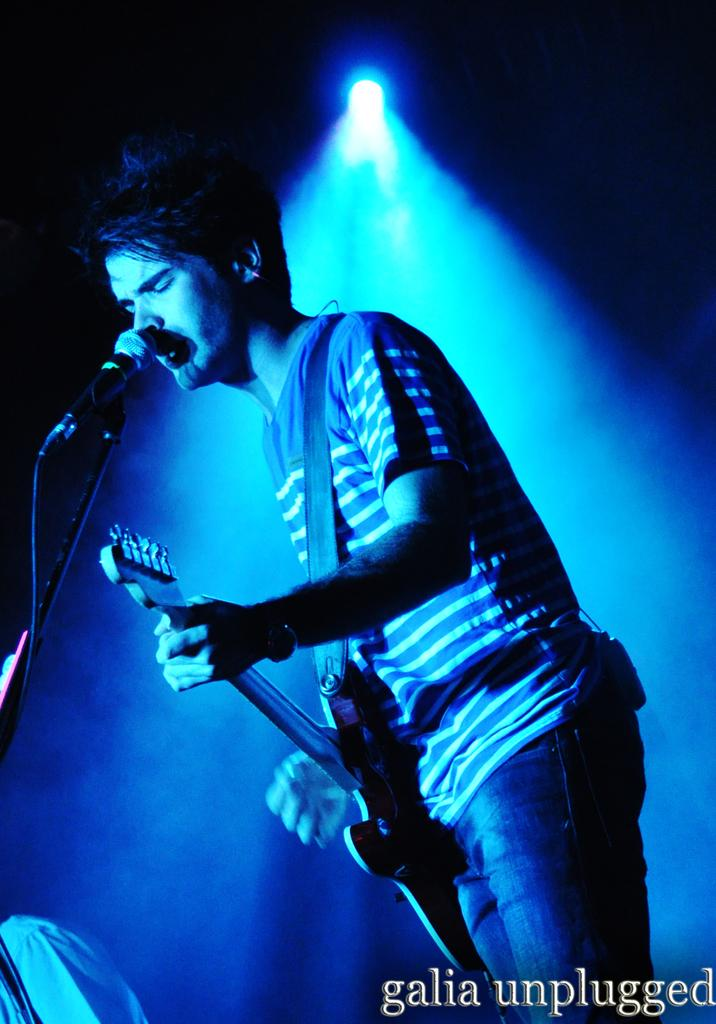What is the main subject of the image? The main subject of the image is a boy. What is the boy doing in the image? The boy is singing on a mic and playing a guitar. Is there any special lighting in the image? Yes, there is a light focusing on the boy. How would you describe the overall lighting in the image? The rest of the image is dark. What type of feast is being prepared in the image? There is no feast being prepared in the image; it features a boy singing and playing a guitar. What kind of metal is used to make the guitar in the image? The image does not provide information about the material used to make the guitar. 